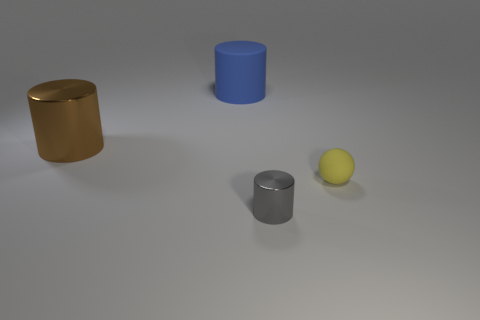Add 4 tiny red objects. How many objects exist? 8 Subtract all balls. How many objects are left? 3 Subtract 1 yellow balls. How many objects are left? 3 Subtract all brown cylinders. Subtract all small gray things. How many objects are left? 2 Add 4 brown shiny objects. How many brown shiny objects are left? 5 Add 2 green rubber things. How many green rubber things exist? 2 